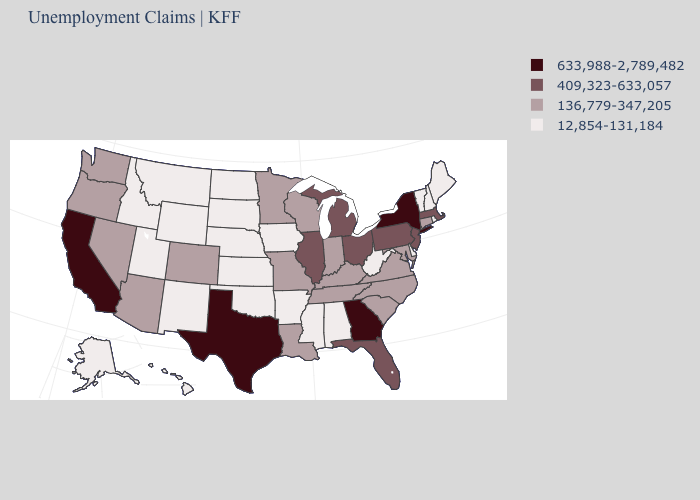Name the states that have a value in the range 12,854-131,184?
Write a very short answer. Alabama, Alaska, Arkansas, Delaware, Hawaii, Idaho, Iowa, Kansas, Maine, Mississippi, Montana, Nebraska, New Hampshire, New Mexico, North Dakota, Oklahoma, Rhode Island, South Dakota, Utah, Vermont, West Virginia, Wyoming. Which states have the highest value in the USA?
Answer briefly. California, Georgia, New York, Texas. What is the value of Washington?
Short answer required. 136,779-347,205. What is the value of New Jersey?
Give a very brief answer. 409,323-633,057. Is the legend a continuous bar?
Give a very brief answer. No. Which states have the lowest value in the West?
Keep it brief. Alaska, Hawaii, Idaho, Montana, New Mexico, Utah, Wyoming. Name the states that have a value in the range 136,779-347,205?
Answer briefly. Arizona, Colorado, Connecticut, Indiana, Kentucky, Louisiana, Maryland, Minnesota, Missouri, Nevada, North Carolina, Oregon, South Carolina, Tennessee, Virginia, Washington, Wisconsin. What is the lowest value in the MidWest?
Give a very brief answer. 12,854-131,184. Does Illinois have a lower value than California?
Give a very brief answer. Yes. Among the states that border New Hampshire , which have the highest value?
Write a very short answer. Massachusetts. Does the first symbol in the legend represent the smallest category?
Short answer required. No. Name the states that have a value in the range 136,779-347,205?
Concise answer only. Arizona, Colorado, Connecticut, Indiana, Kentucky, Louisiana, Maryland, Minnesota, Missouri, Nevada, North Carolina, Oregon, South Carolina, Tennessee, Virginia, Washington, Wisconsin. How many symbols are there in the legend?
Give a very brief answer. 4. Which states have the lowest value in the USA?
Write a very short answer. Alabama, Alaska, Arkansas, Delaware, Hawaii, Idaho, Iowa, Kansas, Maine, Mississippi, Montana, Nebraska, New Hampshire, New Mexico, North Dakota, Oklahoma, Rhode Island, South Dakota, Utah, Vermont, West Virginia, Wyoming. Name the states that have a value in the range 633,988-2,789,482?
Short answer required. California, Georgia, New York, Texas. 